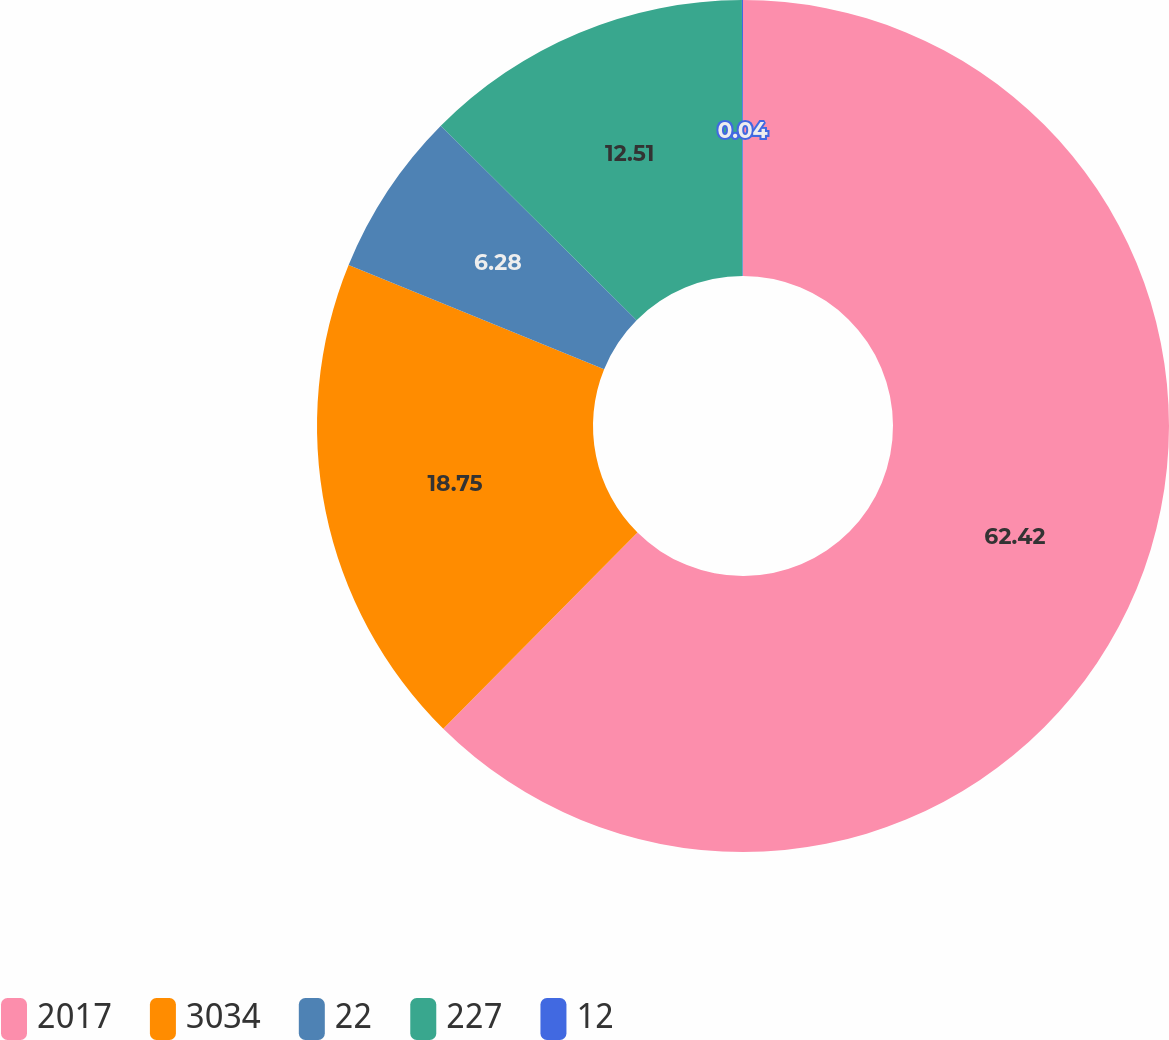Convert chart to OTSL. <chart><loc_0><loc_0><loc_500><loc_500><pie_chart><fcel>2017<fcel>3034<fcel>22<fcel>227<fcel>12<nl><fcel>62.42%<fcel>18.75%<fcel>6.28%<fcel>12.51%<fcel>0.04%<nl></chart> 